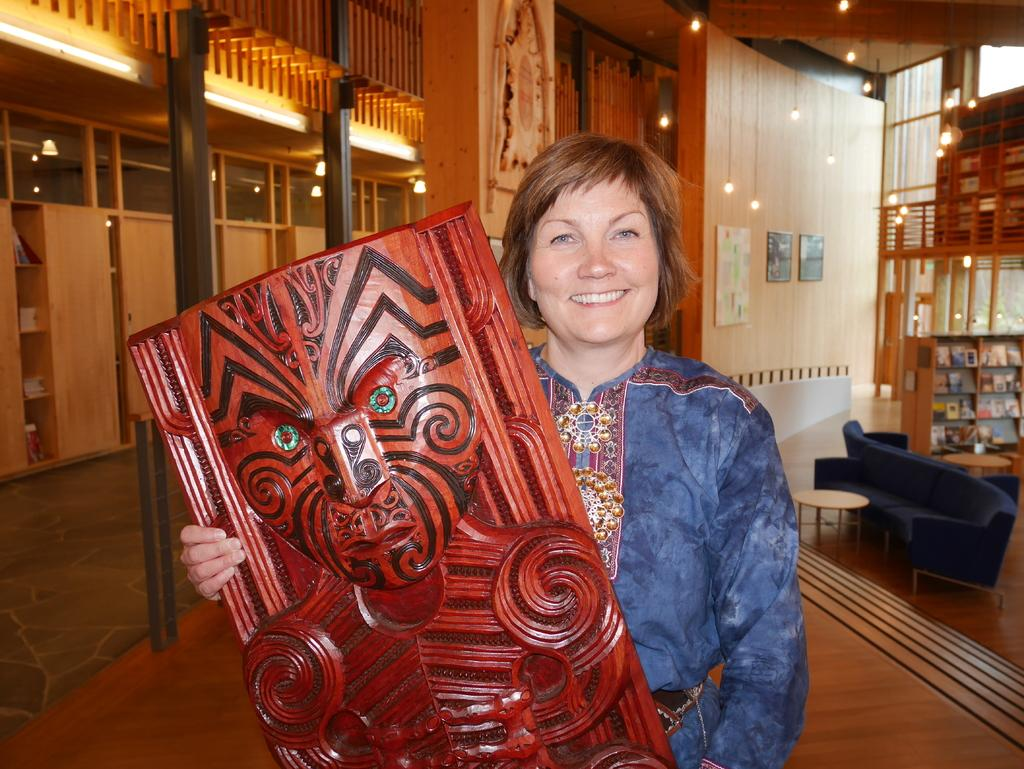What is the primary subject in the image? There is a person in the image. What is the person doing in the image? The person is standing. What is the person holding in her hand? The person is holding a wooden object. What can be seen in the background of the image? There is a blue sofa and bookshelves in the background. Where is the sofa located in relation to the person? The sofa is located to the right of the person. What is hanging from the top of the image? Lights are hanging from the top of the image. What type of stem can be seen growing from the person's head in the image? There is no stem growing from the person's head in the image. Is there a hose visible in the image? There is no hose present in the image. 